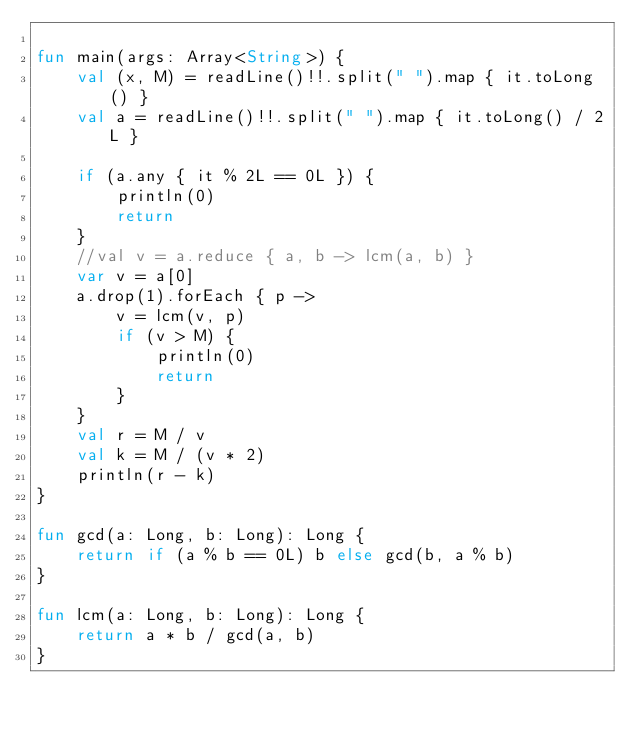<code> <loc_0><loc_0><loc_500><loc_500><_Kotlin_>
fun main(args: Array<String>) {
    val (x, M) = readLine()!!.split(" ").map { it.toLong() }
    val a = readLine()!!.split(" ").map { it.toLong() / 2L }

    if (a.any { it % 2L == 0L }) {
        println(0)
        return
    }
    //val v = a.reduce { a, b -> lcm(a, b) }
    var v = a[0]
    a.drop(1).forEach { p ->
        v = lcm(v, p)
        if (v > M) {
            println(0)
            return
        }
    }
    val r = M / v
    val k = M / (v * 2)
    println(r - k)
}

fun gcd(a: Long, b: Long): Long {
    return if (a % b == 0L) b else gcd(b, a % b)
}

fun lcm(a: Long, b: Long): Long {
    return a * b / gcd(a, b)
}
</code> 